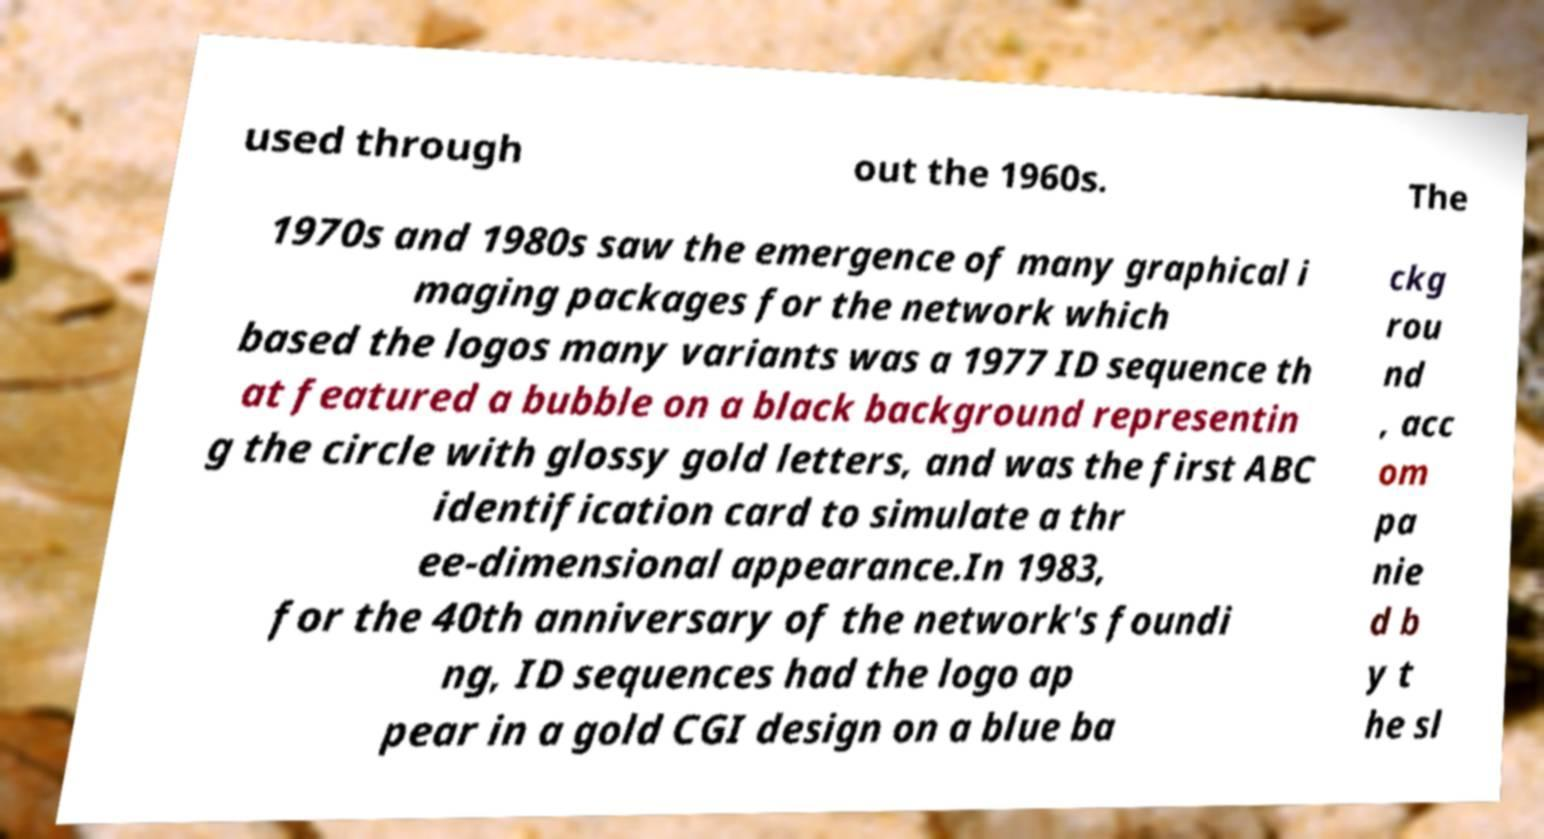Please identify and transcribe the text found in this image. used through out the 1960s. The 1970s and 1980s saw the emergence of many graphical i maging packages for the network which based the logos many variants was a 1977 ID sequence th at featured a bubble on a black background representin g the circle with glossy gold letters, and was the first ABC identification card to simulate a thr ee-dimensional appearance.In 1983, for the 40th anniversary of the network's foundi ng, ID sequences had the logo ap pear in a gold CGI design on a blue ba ckg rou nd , acc om pa nie d b y t he sl 